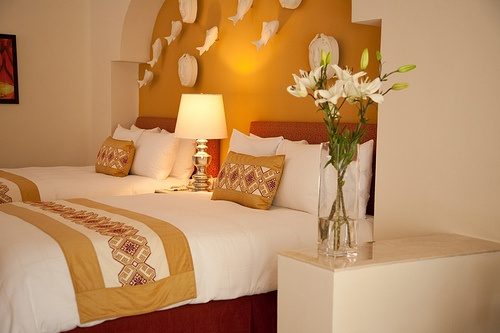Describe the objects in this image and their specific colors. I can see bed in gray, tan, and orange tones, bed in gray, tan, and brown tones, and vase in gray, tan, and olive tones in this image. 